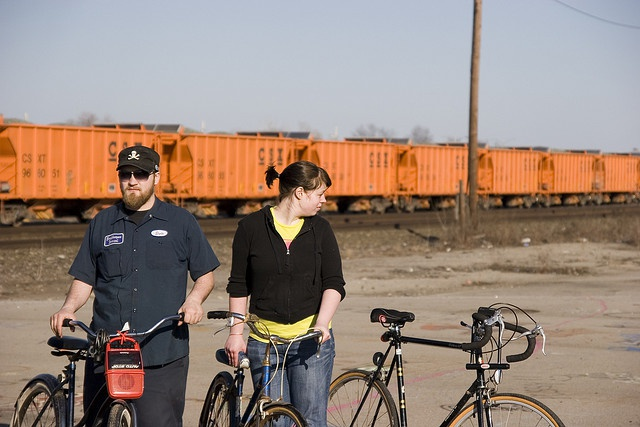Describe the objects in this image and their specific colors. I can see train in darkgray, salmon, red, black, and brown tones, people in darkgray, black, gray, and tan tones, people in darkgray, black, and tan tones, bicycle in darkgray, black, and gray tones, and bicycle in darkgray, black, gray, and tan tones in this image. 